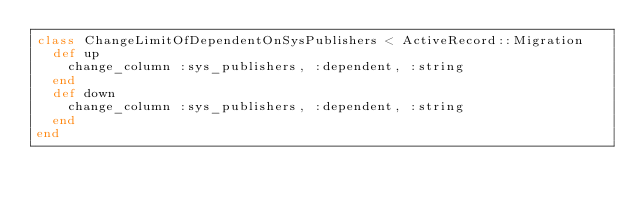<code> <loc_0><loc_0><loc_500><loc_500><_Ruby_>class ChangeLimitOfDependentOnSysPublishers < ActiveRecord::Migration
  def up
    change_column :sys_publishers, :dependent, :string
  end
  def down
    change_column :sys_publishers, :dependent, :string
  end
end
</code> 